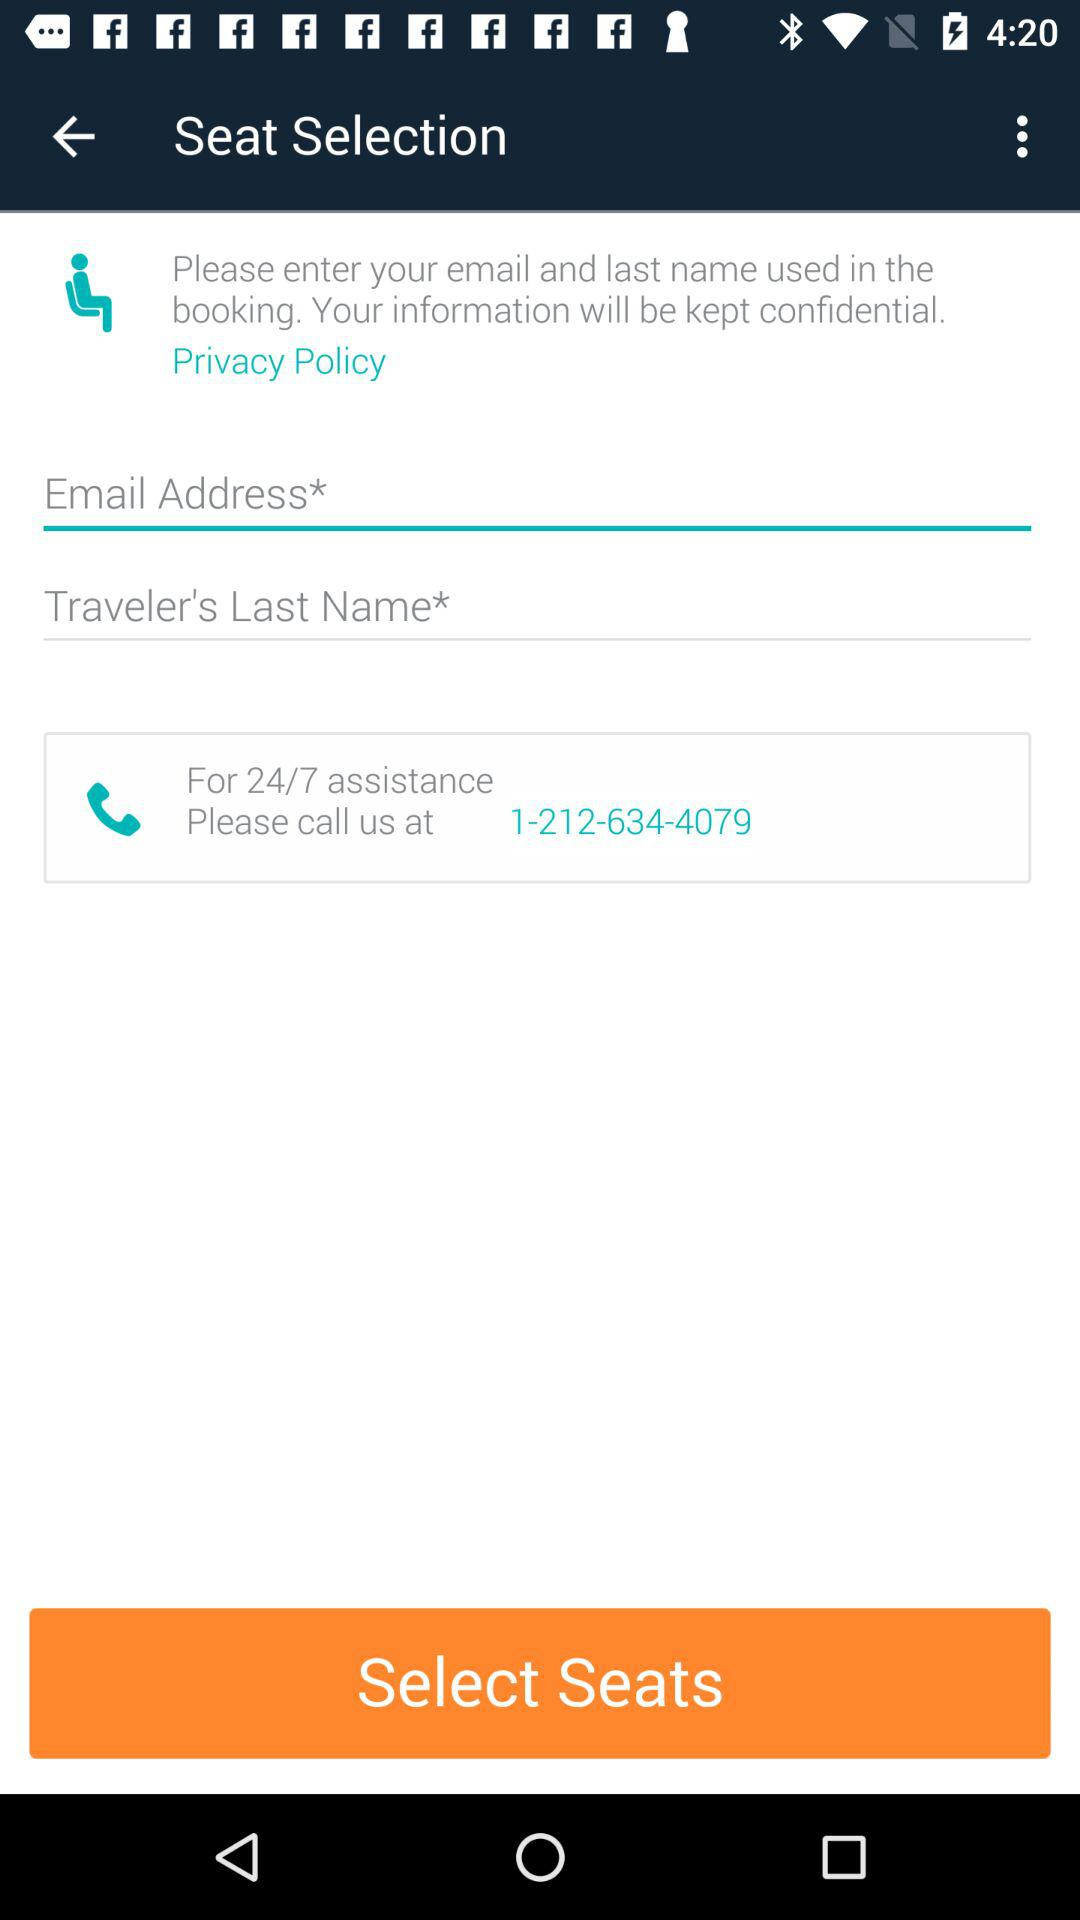How many text inputs are required to enter the contact information? Based on the image, to enter the contact information, you need to fill in two text inputs: one for your 'Email Address' and another for the 'Traveler's Last Name'. Both fields are marked with an asterisk, indicating that they are mandatory for the seat selection process. 